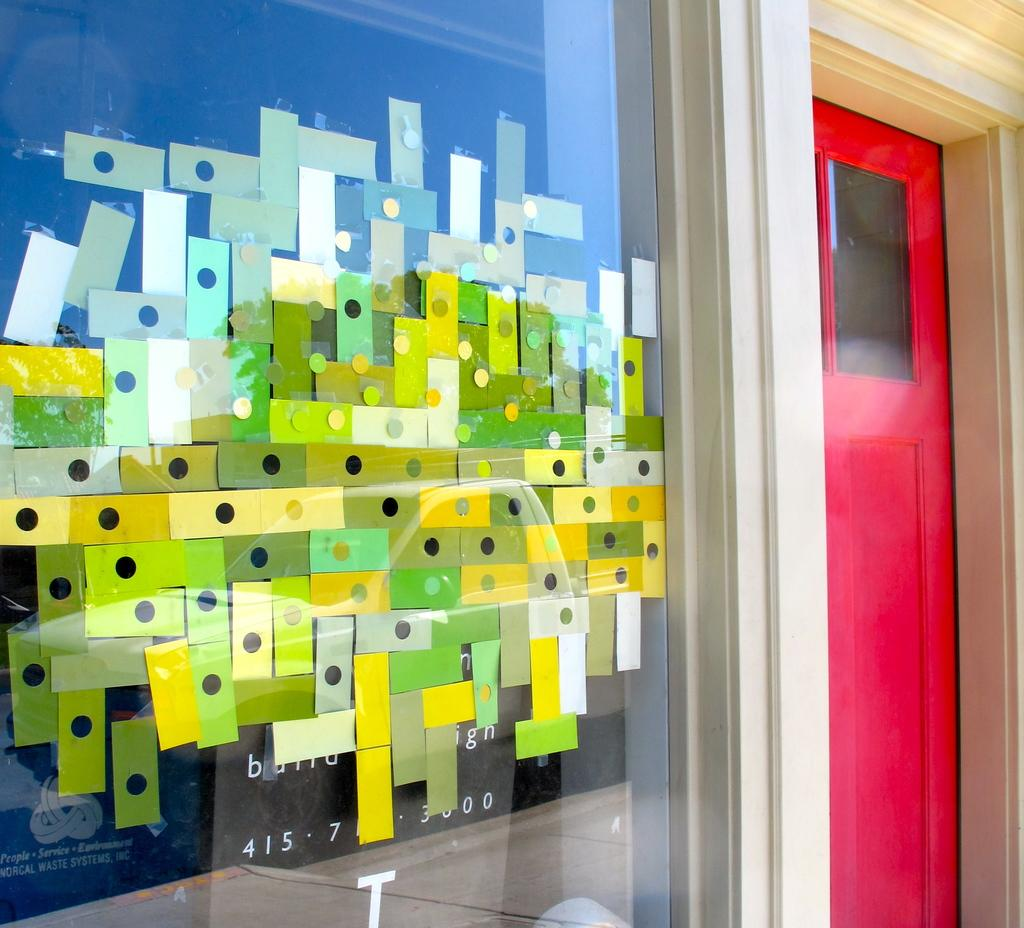What is present on the wall in the image? There is a board on the wall in the image. Where is the door located in the image? The door is on the right side of the image. How many apples are hanging from the board on the wall? There are no apples present in the image. What type of division is taking place on the board in the image? There is no division taking place on the board in the image. 